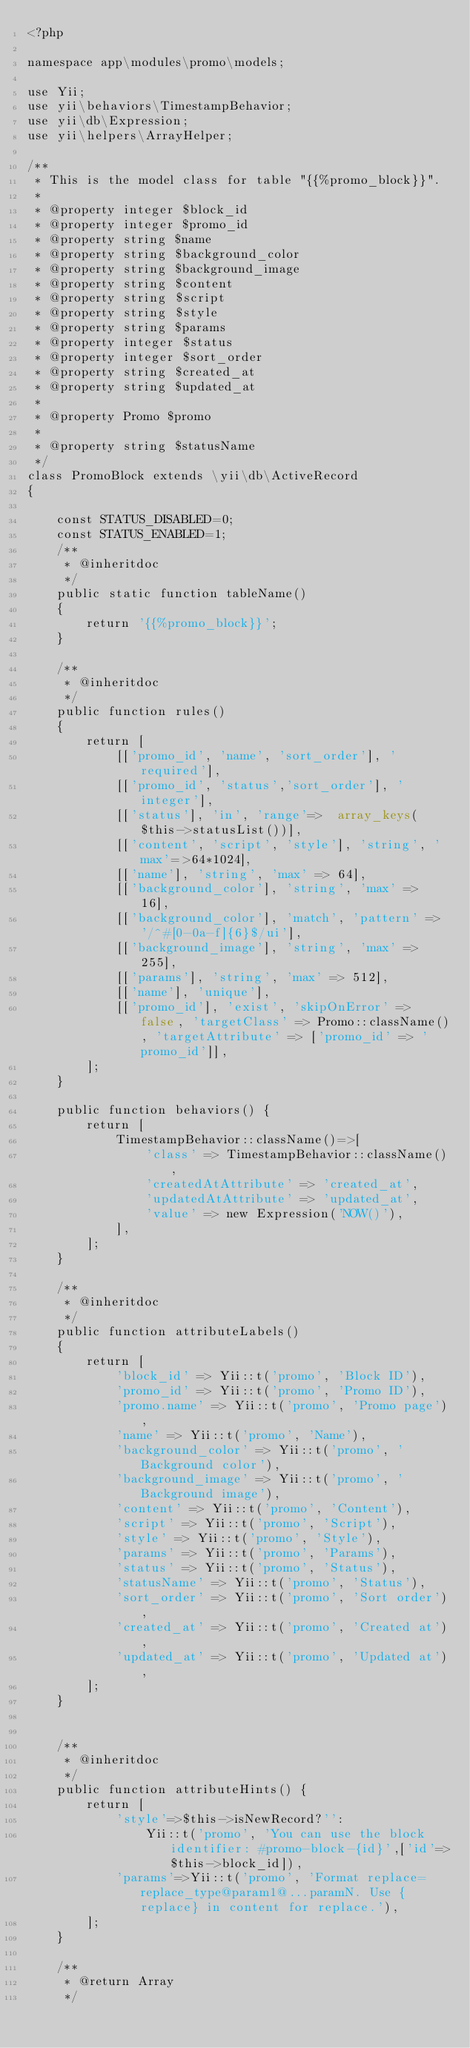<code> <loc_0><loc_0><loc_500><loc_500><_PHP_><?php

namespace app\modules\promo\models;

use Yii;
use yii\behaviors\TimestampBehavior;
use yii\db\Expression;
use yii\helpers\ArrayHelper;

/**
 * This is the model class for table "{{%promo_block}}".
 *
 * @property integer $block_id
 * @property integer $promo_id
 * @property string $name
 * @property string $background_color
 * @property string $background_image
 * @property string $content
 * @property string $script
 * @property string $style
 * @property string $params
 * @property integer $status
 * @property integer $sort_order
 * @property string $created_at
 * @property string $updated_at
 *
 * @property Promo $promo
 *
 * @property string $statusName
 */
class PromoBlock extends \yii\db\ActiveRecord
{

    const STATUS_DISABLED=0;
    const STATUS_ENABLED=1;
    /**
     * @inheritdoc
     */
    public static function tableName()
    {
        return '{{%promo_block}}';
    }

    /**
     * @inheritdoc
     */
    public function rules()
    {
        return [
            [['promo_id', 'name', 'sort_order'], 'required'],
            [['promo_id', 'status','sort_order'], 'integer'],
            [['status'], 'in', 'range'=>  array_keys($this->statusList())],
            [['content', 'script', 'style'], 'string', 'max'=>64*1024],
            [['name'], 'string', 'max' => 64],
            [['background_color'], 'string', 'max' => 16],
            [['background_color'], 'match', 'pattern' => '/^#[0-0a-f]{6}$/ui'],
            [['background_image'], 'string', 'max' => 255],
            [['params'], 'string', 'max' => 512],
            [['name'], 'unique'],
            [['promo_id'], 'exist', 'skipOnError' => false, 'targetClass' => Promo::className(), 'targetAttribute' => ['promo_id' => 'promo_id']],
        ];
    }

    public function behaviors() {
        return [
            TimestampBehavior::className()=>[
                'class' => TimestampBehavior::className(),
                'createdAtAttribute' => 'created_at',
                'updatedAtAttribute' => 'updated_at',
                'value' => new Expression('NOW()'),
            ],
        ];
    }

    /**
     * @inheritdoc
     */
    public function attributeLabels()
    {
        return [
            'block_id' => Yii::t('promo', 'Block ID'),
            'promo_id' => Yii::t('promo', 'Promo ID'),
            'promo.name' => Yii::t('promo', 'Promo page'),
            'name' => Yii::t('promo', 'Name'),
            'background_color' => Yii::t('promo', 'Background color'),
            'background_image' => Yii::t('promo', 'Background image'),
            'content' => Yii::t('promo', 'Content'),
            'script' => Yii::t('promo', 'Script'),
            'style' => Yii::t('promo', 'Style'),
            'params' => Yii::t('promo', 'Params'),
            'status' => Yii::t('promo', 'Status'),
            'statusName' => Yii::t('promo', 'Status'),
            'sort_order' => Yii::t('promo', 'Sort order'),
            'created_at' => Yii::t('promo', 'Created at'),
            'updated_at' => Yii::t('promo', 'Updated at'),
        ];
    }


    /**
     * @inheritdoc
     */
    public function attributeHints() {
        return [
            'style'=>$this->isNewRecord?'':
                Yii::t('promo', 'You can use the block identifier: #promo-block-{id}',['id'=>$this->block_id]),
            'params'=>Yii::t('promo', 'Format replace=replace_type@param1@...paramN. Use {replace} in content for replace.'),
        ];
    }

    /**
     * @return Array
     */</code> 